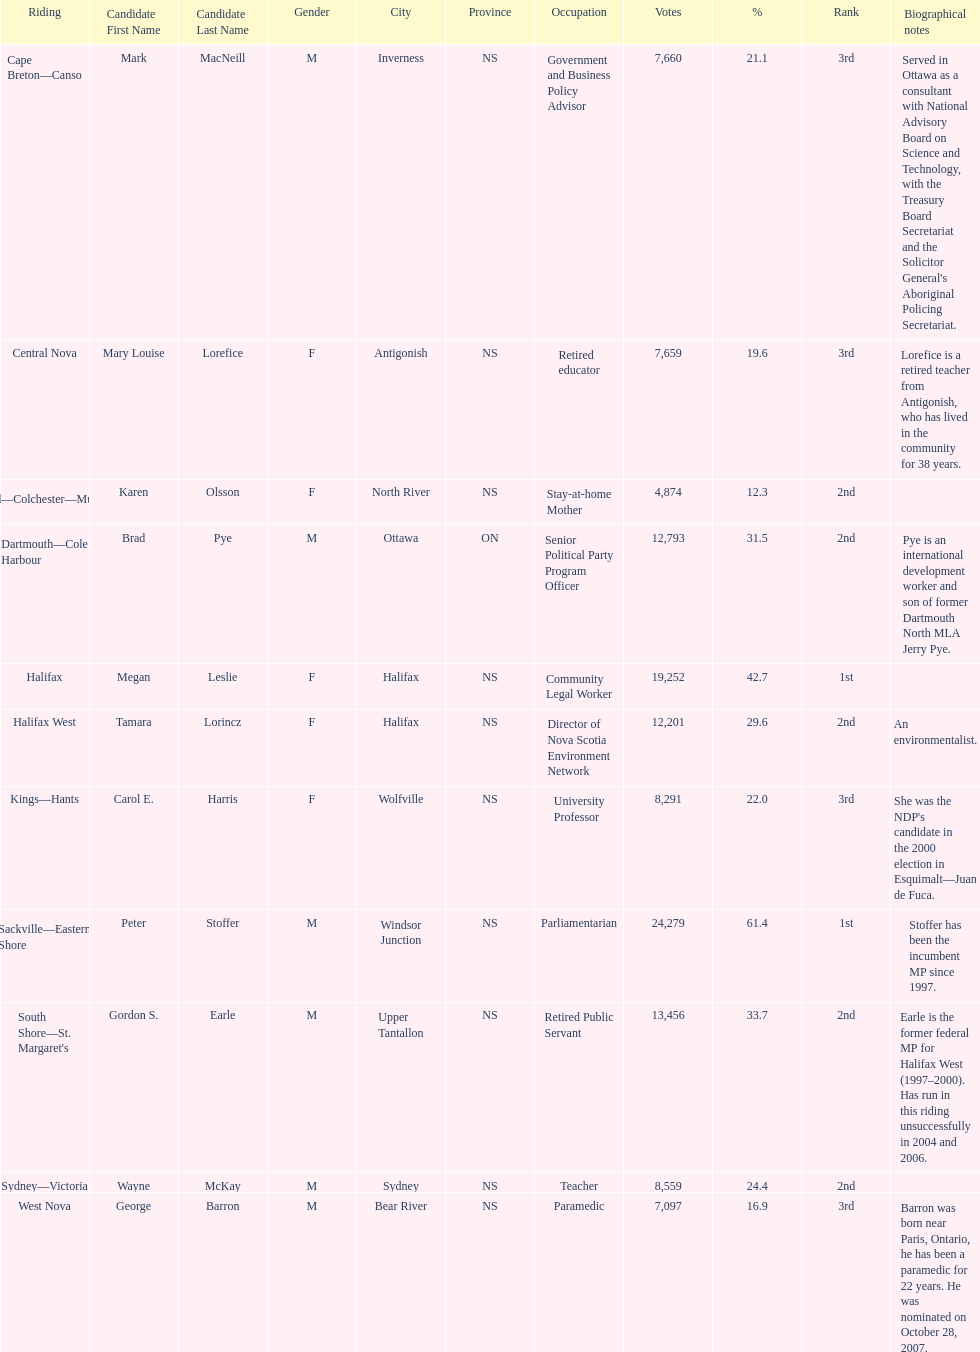What is the first riding? Cape Breton-Canso. 